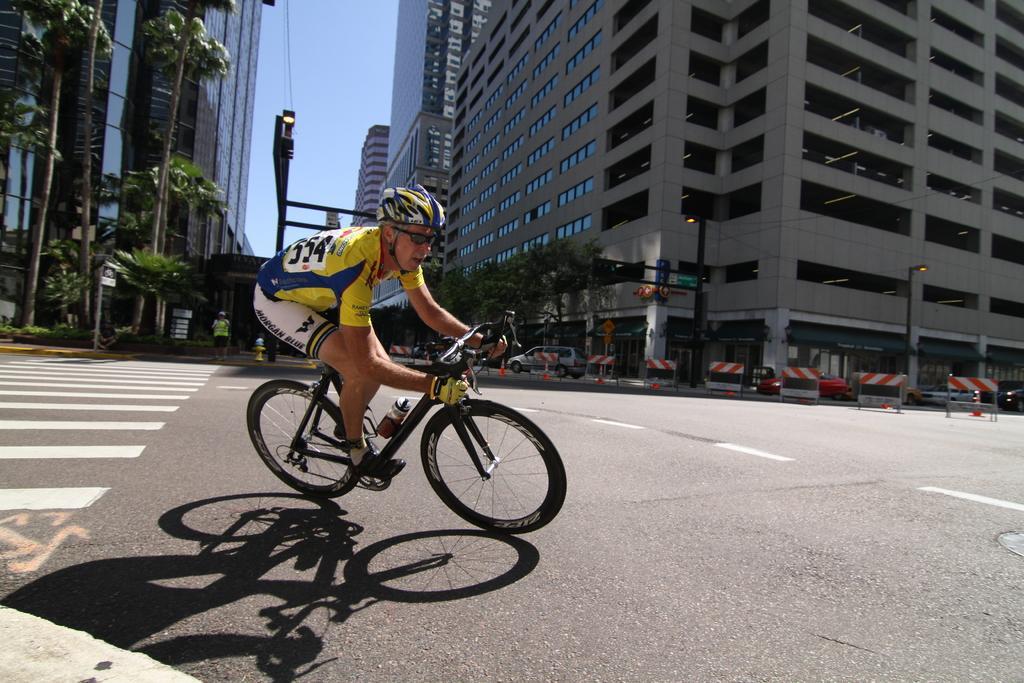Could you give a brief overview of what you see in this image? In this image there is a man riding a bicycle in the center. In the background there are buildings, poles, trees, barricades, cars and there is a person. 